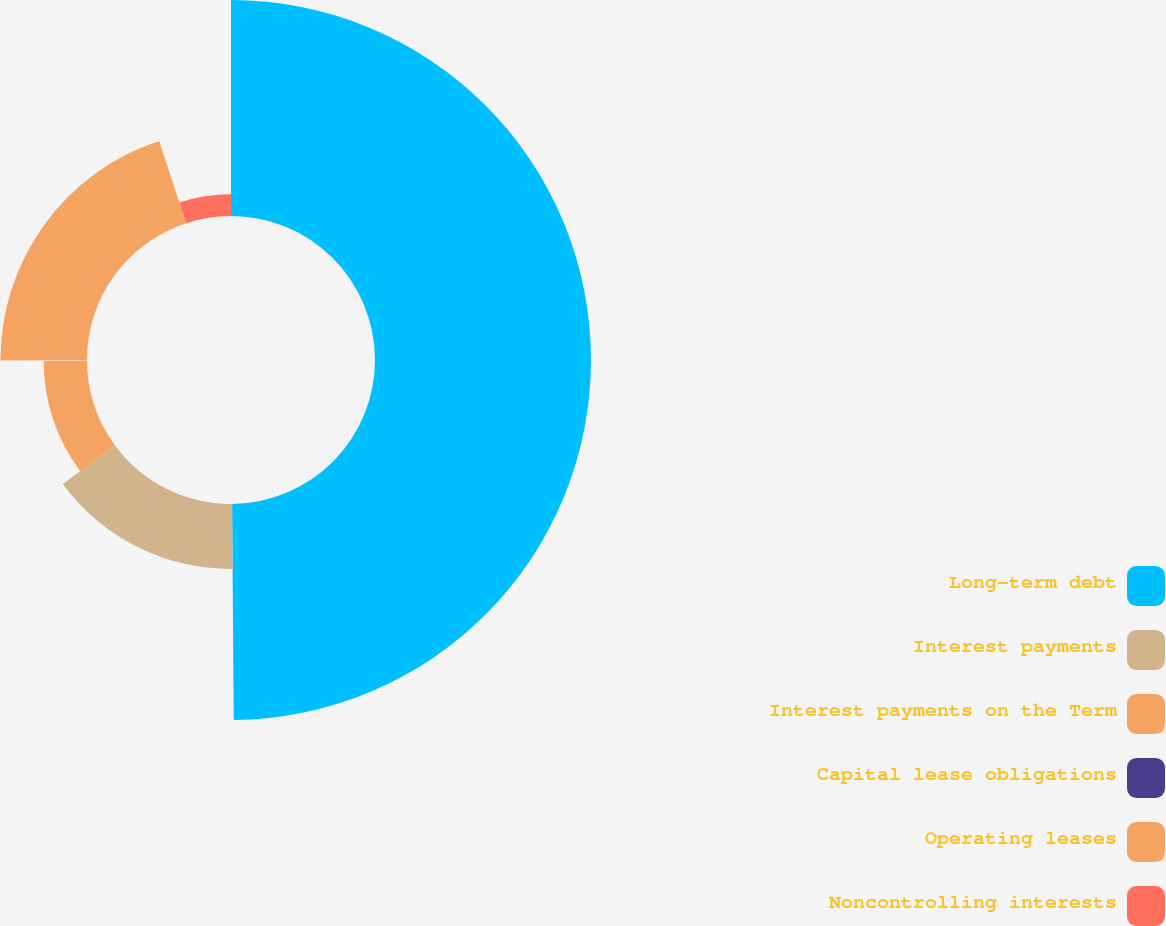Convert chart to OTSL. <chart><loc_0><loc_0><loc_500><loc_500><pie_chart><fcel>Long-term debt<fcel>Interest payments<fcel>Interest payments on the Term<fcel>Capital lease obligations<fcel>Operating leases<fcel>Noncontrolling interests<nl><fcel>49.88%<fcel>15.01%<fcel>10.02%<fcel>0.06%<fcel>19.99%<fcel>5.04%<nl></chart> 